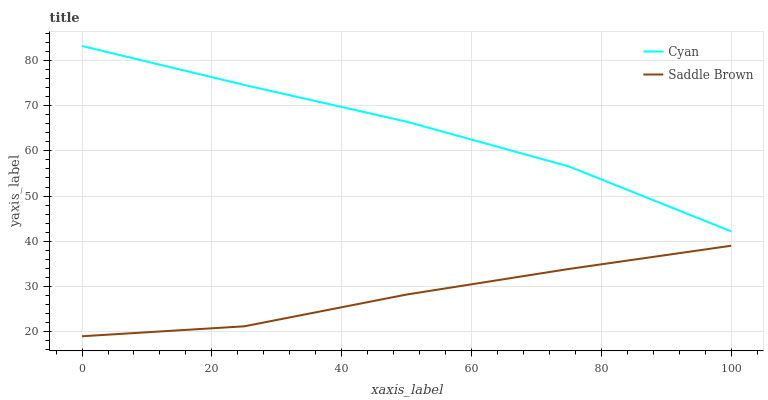Does Saddle Brown have the minimum area under the curve?
Answer yes or no. Yes. Does Cyan have the maximum area under the curve?
Answer yes or no. Yes. Does Saddle Brown have the maximum area under the curve?
Answer yes or no. No. Is Saddle Brown the smoothest?
Answer yes or no. Yes. Is Cyan the roughest?
Answer yes or no. Yes. Is Saddle Brown the roughest?
Answer yes or no. No. Does Saddle Brown have the lowest value?
Answer yes or no. Yes. Does Cyan have the highest value?
Answer yes or no. Yes. Does Saddle Brown have the highest value?
Answer yes or no. No. Is Saddle Brown less than Cyan?
Answer yes or no. Yes. Is Cyan greater than Saddle Brown?
Answer yes or no. Yes. Does Saddle Brown intersect Cyan?
Answer yes or no. No. 